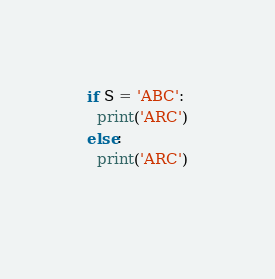Convert code to text. <code><loc_0><loc_0><loc_500><loc_500><_Python_>if S = 'ABC':
  print('ARC')
else:
  print('ARC')
  </code> 